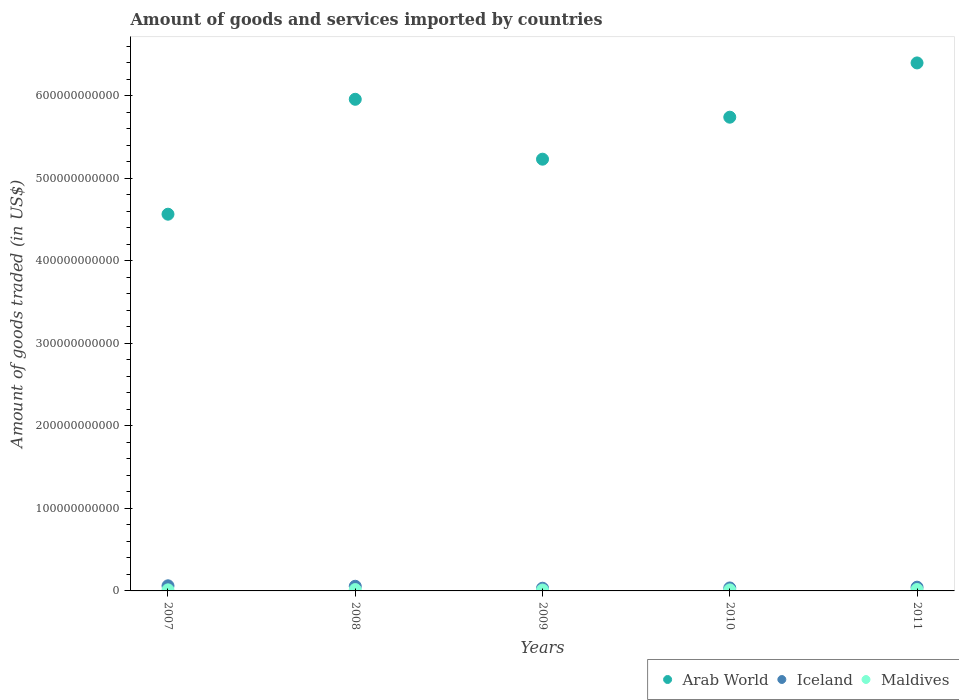Is the number of dotlines equal to the number of legend labels?
Offer a terse response. Yes. What is the total amount of goods and services imported in Iceland in 2011?
Keep it short and to the point. 4.54e+09. Across all years, what is the maximum total amount of goods and services imported in Arab World?
Provide a short and direct response. 6.40e+11. Across all years, what is the minimum total amount of goods and services imported in Arab World?
Your answer should be compact. 4.57e+11. In which year was the total amount of goods and services imported in Maldives maximum?
Give a very brief answer. 2011. In which year was the total amount of goods and services imported in Arab World minimum?
Ensure brevity in your answer.  2007. What is the total total amount of goods and services imported in Maldives in the graph?
Provide a succinct answer. 6.99e+09. What is the difference between the total amount of goods and services imported in Iceland in 2008 and that in 2011?
Offer a terse response. 1.10e+09. What is the difference between the total amount of goods and services imported in Maldives in 2007 and the total amount of goods and services imported in Iceland in 2010?
Your answer should be compact. -2.29e+09. What is the average total amount of goods and services imported in Arab World per year?
Your response must be concise. 5.58e+11. In the year 2010, what is the difference between the total amount of goods and services imported in Maldives and total amount of goods and services imported in Arab World?
Provide a succinct answer. -5.73e+11. What is the ratio of the total amount of goods and services imported in Maldives in 2010 to that in 2011?
Provide a succinct answer. 0.72. Is the difference between the total amount of goods and services imported in Maldives in 2009 and 2011 greater than the difference between the total amount of goods and services imported in Arab World in 2009 and 2011?
Offer a very short reply. Yes. What is the difference between the highest and the second highest total amount of goods and services imported in Arab World?
Provide a succinct answer. 4.41e+1. What is the difference between the highest and the lowest total amount of goods and services imported in Iceland?
Your response must be concise. 2.95e+09. In how many years, is the total amount of goods and services imported in Iceland greater than the average total amount of goods and services imported in Iceland taken over all years?
Offer a very short reply. 2. Is it the case that in every year, the sum of the total amount of goods and services imported in Iceland and total amount of goods and services imported in Maldives  is greater than the total amount of goods and services imported in Arab World?
Offer a very short reply. No. Is the total amount of goods and services imported in Maldives strictly less than the total amount of goods and services imported in Arab World over the years?
Provide a short and direct response. Yes. What is the difference between two consecutive major ticks on the Y-axis?
Your response must be concise. 1.00e+11. Are the values on the major ticks of Y-axis written in scientific E-notation?
Your response must be concise. No. Where does the legend appear in the graph?
Provide a short and direct response. Bottom right. How are the legend labels stacked?
Provide a short and direct response. Horizontal. What is the title of the graph?
Provide a succinct answer. Amount of goods and services imported by countries. Does "Ghana" appear as one of the legend labels in the graph?
Offer a very short reply. No. What is the label or title of the X-axis?
Your answer should be very brief. Years. What is the label or title of the Y-axis?
Your answer should be very brief. Amount of goods traded (in US$). What is the Amount of goods traded (in US$) of Arab World in 2007?
Give a very brief answer. 4.57e+11. What is the Amount of goods traded (in US$) in Iceland in 2007?
Give a very brief answer. 6.21e+09. What is the Amount of goods traded (in US$) in Maldives in 2007?
Ensure brevity in your answer.  1.30e+09. What is the Amount of goods traded (in US$) in Arab World in 2008?
Ensure brevity in your answer.  5.96e+11. What is the Amount of goods traded (in US$) of Iceland in 2008?
Provide a short and direct response. 5.64e+09. What is the Amount of goods traded (in US$) of Maldives in 2008?
Give a very brief answer. 1.65e+09. What is the Amount of goods traded (in US$) of Arab World in 2009?
Give a very brief answer. 5.23e+11. What is the Amount of goods traded (in US$) of Iceland in 2009?
Your response must be concise. 3.26e+09. What is the Amount of goods traded (in US$) in Maldives in 2009?
Ensure brevity in your answer.  1.08e+09. What is the Amount of goods traded (in US$) of Arab World in 2010?
Provide a succinct answer. 5.74e+11. What is the Amount of goods traded (in US$) in Iceland in 2010?
Ensure brevity in your answer.  3.60e+09. What is the Amount of goods traded (in US$) in Maldives in 2010?
Your response must be concise. 1.24e+09. What is the Amount of goods traded (in US$) of Arab World in 2011?
Your response must be concise. 6.40e+11. What is the Amount of goods traded (in US$) of Iceland in 2011?
Ensure brevity in your answer.  4.54e+09. What is the Amount of goods traded (in US$) in Maldives in 2011?
Make the answer very short. 1.72e+09. Across all years, what is the maximum Amount of goods traded (in US$) of Arab World?
Give a very brief answer. 6.40e+11. Across all years, what is the maximum Amount of goods traded (in US$) of Iceland?
Your answer should be very brief. 6.21e+09. Across all years, what is the maximum Amount of goods traded (in US$) in Maldives?
Offer a very short reply. 1.72e+09. Across all years, what is the minimum Amount of goods traded (in US$) of Arab World?
Your answer should be very brief. 4.57e+11. Across all years, what is the minimum Amount of goods traded (in US$) in Iceland?
Ensure brevity in your answer.  3.26e+09. Across all years, what is the minimum Amount of goods traded (in US$) of Maldives?
Ensure brevity in your answer.  1.08e+09. What is the total Amount of goods traded (in US$) of Arab World in the graph?
Ensure brevity in your answer.  2.79e+12. What is the total Amount of goods traded (in US$) of Iceland in the graph?
Make the answer very short. 2.33e+1. What is the total Amount of goods traded (in US$) of Maldives in the graph?
Ensure brevity in your answer.  6.99e+09. What is the difference between the Amount of goods traded (in US$) of Arab World in 2007 and that in 2008?
Ensure brevity in your answer.  -1.39e+11. What is the difference between the Amount of goods traded (in US$) in Iceland in 2007 and that in 2008?
Offer a terse response. 5.66e+08. What is the difference between the Amount of goods traded (in US$) of Maldives in 2007 and that in 2008?
Give a very brief answer. -3.44e+08. What is the difference between the Amount of goods traded (in US$) of Arab World in 2007 and that in 2009?
Ensure brevity in your answer.  -6.67e+1. What is the difference between the Amount of goods traded (in US$) in Iceland in 2007 and that in 2009?
Give a very brief answer. 2.95e+09. What is the difference between the Amount of goods traded (in US$) in Maldives in 2007 and that in 2009?
Your response must be concise. 2.23e+08. What is the difference between the Amount of goods traded (in US$) of Arab World in 2007 and that in 2010?
Keep it short and to the point. -1.18e+11. What is the difference between the Amount of goods traded (in US$) in Iceland in 2007 and that in 2010?
Keep it short and to the point. 2.61e+09. What is the difference between the Amount of goods traded (in US$) of Maldives in 2007 and that in 2010?
Provide a succinct answer. 6.30e+07. What is the difference between the Amount of goods traded (in US$) in Arab World in 2007 and that in 2011?
Give a very brief answer. -1.83e+11. What is the difference between the Amount of goods traded (in US$) of Iceland in 2007 and that in 2011?
Offer a terse response. 1.67e+09. What is the difference between the Amount of goods traded (in US$) in Maldives in 2007 and that in 2011?
Keep it short and to the point. -4.12e+08. What is the difference between the Amount of goods traded (in US$) of Arab World in 2008 and that in 2009?
Offer a terse response. 7.26e+1. What is the difference between the Amount of goods traded (in US$) in Iceland in 2008 and that in 2009?
Ensure brevity in your answer.  2.38e+09. What is the difference between the Amount of goods traded (in US$) of Maldives in 2008 and that in 2009?
Your answer should be very brief. 5.67e+08. What is the difference between the Amount of goods traded (in US$) in Arab World in 2008 and that in 2010?
Make the answer very short. 2.17e+1. What is the difference between the Amount of goods traded (in US$) in Iceland in 2008 and that in 2010?
Give a very brief answer. 2.05e+09. What is the difference between the Amount of goods traded (in US$) of Maldives in 2008 and that in 2010?
Provide a short and direct response. 4.07e+08. What is the difference between the Amount of goods traded (in US$) of Arab World in 2008 and that in 2011?
Give a very brief answer. -4.41e+1. What is the difference between the Amount of goods traded (in US$) in Iceland in 2008 and that in 2011?
Provide a short and direct response. 1.10e+09. What is the difference between the Amount of goods traded (in US$) of Maldives in 2008 and that in 2011?
Offer a terse response. -6.78e+07. What is the difference between the Amount of goods traded (in US$) of Arab World in 2009 and that in 2010?
Make the answer very short. -5.09e+1. What is the difference between the Amount of goods traded (in US$) of Iceland in 2009 and that in 2010?
Make the answer very short. -3.34e+08. What is the difference between the Amount of goods traded (in US$) in Maldives in 2009 and that in 2010?
Ensure brevity in your answer.  -1.60e+08. What is the difference between the Amount of goods traded (in US$) of Arab World in 2009 and that in 2011?
Offer a very short reply. -1.17e+11. What is the difference between the Amount of goods traded (in US$) of Iceland in 2009 and that in 2011?
Keep it short and to the point. -1.28e+09. What is the difference between the Amount of goods traded (in US$) in Maldives in 2009 and that in 2011?
Provide a succinct answer. -6.35e+08. What is the difference between the Amount of goods traded (in US$) of Arab World in 2010 and that in 2011?
Provide a succinct answer. -6.58e+1. What is the difference between the Amount of goods traded (in US$) of Iceland in 2010 and that in 2011?
Ensure brevity in your answer.  -9.44e+08. What is the difference between the Amount of goods traded (in US$) in Maldives in 2010 and that in 2011?
Your response must be concise. -4.75e+08. What is the difference between the Amount of goods traded (in US$) in Arab World in 2007 and the Amount of goods traded (in US$) in Iceland in 2008?
Offer a very short reply. 4.51e+11. What is the difference between the Amount of goods traded (in US$) in Arab World in 2007 and the Amount of goods traded (in US$) in Maldives in 2008?
Your response must be concise. 4.55e+11. What is the difference between the Amount of goods traded (in US$) in Iceland in 2007 and the Amount of goods traded (in US$) in Maldives in 2008?
Make the answer very short. 4.56e+09. What is the difference between the Amount of goods traded (in US$) of Arab World in 2007 and the Amount of goods traded (in US$) of Iceland in 2009?
Your answer should be compact. 4.53e+11. What is the difference between the Amount of goods traded (in US$) of Arab World in 2007 and the Amount of goods traded (in US$) of Maldives in 2009?
Offer a very short reply. 4.55e+11. What is the difference between the Amount of goods traded (in US$) of Iceland in 2007 and the Amount of goods traded (in US$) of Maldives in 2009?
Provide a succinct answer. 5.13e+09. What is the difference between the Amount of goods traded (in US$) in Arab World in 2007 and the Amount of goods traded (in US$) in Iceland in 2010?
Offer a very short reply. 4.53e+11. What is the difference between the Amount of goods traded (in US$) in Arab World in 2007 and the Amount of goods traded (in US$) in Maldives in 2010?
Your response must be concise. 4.55e+11. What is the difference between the Amount of goods traded (in US$) in Iceland in 2007 and the Amount of goods traded (in US$) in Maldives in 2010?
Give a very brief answer. 4.97e+09. What is the difference between the Amount of goods traded (in US$) of Arab World in 2007 and the Amount of goods traded (in US$) of Iceland in 2011?
Offer a very short reply. 4.52e+11. What is the difference between the Amount of goods traded (in US$) of Arab World in 2007 and the Amount of goods traded (in US$) of Maldives in 2011?
Make the answer very short. 4.55e+11. What is the difference between the Amount of goods traded (in US$) in Iceland in 2007 and the Amount of goods traded (in US$) in Maldives in 2011?
Offer a very short reply. 4.49e+09. What is the difference between the Amount of goods traded (in US$) of Arab World in 2008 and the Amount of goods traded (in US$) of Iceland in 2009?
Give a very brief answer. 5.93e+11. What is the difference between the Amount of goods traded (in US$) in Arab World in 2008 and the Amount of goods traded (in US$) in Maldives in 2009?
Your answer should be compact. 5.95e+11. What is the difference between the Amount of goods traded (in US$) of Iceland in 2008 and the Amount of goods traded (in US$) of Maldives in 2009?
Keep it short and to the point. 4.56e+09. What is the difference between the Amount of goods traded (in US$) of Arab World in 2008 and the Amount of goods traded (in US$) of Iceland in 2010?
Provide a short and direct response. 5.92e+11. What is the difference between the Amount of goods traded (in US$) in Arab World in 2008 and the Amount of goods traded (in US$) in Maldives in 2010?
Offer a very short reply. 5.95e+11. What is the difference between the Amount of goods traded (in US$) of Iceland in 2008 and the Amount of goods traded (in US$) of Maldives in 2010?
Your answer should be compact. 4.40e+09. What is the difference between the Amount of goods traded (in US$) in Arab World in 2008 and the Amount of goods traded (in US$) in Iceland in 2011?
Provide a succinct answer. 5.91e+11. What is the difference between the Amount of goods traded (in US$) in Arab World in 2008 and the Amount of goods traded (in US$) in Maldives in 2011?
Make the answer very short. 5.94e+11. What is the difference between the Amount of goods traded (in US$) of Iceland in 2008 and the Amount of goods traded (in US$) of Maldives in 2011?
Keep it short and to the point. 3.93e+09. What is the difference between the Amount of goods traded (in US$) in Arab World in 2009 and the Amount of goods traded (in US$) in Iceland in 2010?
Offer a terse response. 5.20e+11. What is the difference between the Amount of goods traded (in US$) in Arab World in 2009 and the Amount of goods traded (in US$) in Maldives in 2010?
Offer a very short reply. 5.22e+11. What is the difference between the Amount of goods traded (in US$) in Iceland in 2009 and the Amount of goods traded (in US$) in Maldives in 2010?
Provide a succinct answer. 2.02e+09. What is the difference between the Amount of goods traded (in US$) of Arab World in 2009 and the Amount of goods traded (in US$) of Iceland in 2011?
Your answer should be very brief. 5.19e+11. What is the difference between the Amount of goods traded (in US$) in Arab World in 2009 and the Amount of goods traded (in US$) in Maldives in 2011?
Offer a terse response. 5.22e+11. What is the difference between the Amount of goods traded (in US$) of Iceland in 2009 and the Amount of goods traded (in US$) of Maldives in 2011?
Your response must be concise. 1.55e+09. What is the difference between the Amount of goods traded (in US$) of Arab World in 2010 and the Amount of goods traded (in US$) of Iceland in 2011?
Your answer should be very brief. 5.70e+11. What is the difference between the Amount of goods traded (in US$) of Arab World in 2010 and the Amount of goods traded (in US$) of Maldives in 2011?
Your response must be concise. 5.72e+11. What is the difference between the Amount of goods traded (in US$) in Iceland in 2010 and the Amount of goods traded (in US$) in Maldives in 2011?
Provide a succinct answer. 1.88e+09. What is the average Amount of goods traded (in US$) in Arab World per year?
Your response must be concise. 5.58e+11. What is the average Amount of goods traded (in US$) of Iceland per year?
Offer a terse response. 4.65e+09. What is the average Amount of goods traded (in US$) of Maldives per year?
Make the answer very short. 1.40e+09. In the year 2007, what is the difference between the Amount of goods traded (in US$) of Arab World and Amount of goods traded (in US$) of Iceland?
Offer a very short reply. 4.50e+11. In the year 2007, what is the difference between the Amount of goods traded (in US$) of Arab World and Amount of goods traded (in US$) of Maldives?
Provide a succinct answer. 4.55e+11. In the year 2007, what is the difference between the Amount of goods traded (in US$) in Iceland and Amount of goods traded (in US$) in Maldives?
Ensure brevity in your answer.  4.91e+09. In the year 2008, what is the difference between the Amount of goods traded (in US$) in Arab World and Amount of goods traded (in US$) in Iceland?
Provide a short and direct response. 5.90e+11. In the year 2008, what is the difference between the Amount of goods traded (in US$) in Arab World and Amount of goods traded (in US$) in Maldives?
Keep it short and to the point. 5.94e+11. In the year 2008, what is the difference between the Amount of goods traded (in US$) of Iceland and Amount of goods traded (in US$) of Maldives?
Your response must be concise. 4.00e+09. In the year 2009, what is the difference between the Amount of goods traded (in US$) of Arab World and Amount of goods traded (in US$) of Iceland?
Give a very brief answer. 5.20e+11. In the year 2009, what is the difference between the Amount of goods traded (in US$) in Arab World and Amount of goods traded (in US$) in Maldives?
Offer a terse response. 5.22e+11. In the year 2009, what is the difference between the Amount of goods traded (in US$) in Iceland and Amount of goods traded (in US$) in Maldives?
Provide a short and direct response. 2.18e+09. In the year 2010, what is the difference between the Amount of goods traded (in US$) in Arab World and Amount of goods traded (in US$) in Iceland?
Your answer should be very brief. 5.71e+11. In the year 2010, what is the difference between the Amount of goods traded (in US$) of Arab World and Amount of goods traded (in US$) of Maldives?
Make the answer very short. 5.73e+11. In the year 2010, what is the difference between the Amount of goods traded (in US$) in Iceland and Amount of goods traded (in US$) in Maldives?
Your answer should be compact. 2.35e+09. In the year 2011, what is the difference between the Amount of goods traded (in US$) of Arab World and Amount of goods traded (in US$) of Iceland?
Make the answer very short. 6.35e+11. In the year 2011, what is the difference between the Amount of goods traded (in US$) of Arab World and Amount of goods traded (in US$) of Maldives?
Your answer should be very brief. 6.38e+11. In the year 2011, what is the difference between the Amount of goods traded (in US$) of Iceland and Amount of goods traded (in US$) of Maldives?
Ensure brevity in your answer.  2.82e+09. What is the ratio of the Amount of goods traded (in US$) in Arab World in 2007 to that in 2008?
Your answer should be compact. 0.77. What is the ratio of the Amount of goods traded (in US$) in Iceland in 2007 to that in 2008?
Keep it short and to the point. 1.1. What is the ratio of the Amount of goods traded (in US$) of Maldives in 2007 to that in 2008?
Keep it short and to the point. 0.79. What is the ratio of the Amount of goods traded (in US$) in Arab World in 2007 to that in 2009?
Your answer should be very brief. 0.87. What is the ratio of the Amount of goods traded (in US$) in Iceland in 2007 to that in 2009?
Your response must be concise. 1.9. What is the ratio of the Amount of goods traded (in US$) of Maldives in 2007 to that in 2009?
Your answer should be compact. 1.21. What is the ratio of the Amount of goods traded (in US$) in Arab World in 2007 to that in 2010?
Ensure brevity in your answer.  0.8. What is the ratio of the Amount of goods traded (in US$) in Iceland in 2007 to that in 2010?
Your answer should be compact. 1.73. What is the ratio of the Amount of goods traded (in US$) in Maldives in 2007 to that in 2010?
Keep it short and to the point. 1.05. What is the ratio of the Amount of goods traded (in US$) of Arab World in 2007 to that in 2011?
Ensure brevity in your answer.  0.71. What is the ratio of the Amount of goods traded (in US$) of Iceland in 2007 to that in 2011?
Ensure brevity in your answer.  1.37. What is the ratio of the Amount of goods traded (in US$) of Maldives in 2007 to that in 2011?
Make the answer very short. 0.76. What is the ratio of the Amount of goods traded (in US$) of Arab World in 2008 to that in 2009?
Your response must be concise. 1.14. What is the ratio of the Amount of goods traded (in US$) of Iceland in 2008 to that in 2009?
Your response must be concise. 1.73. What is the ratio of the Amount of goods traded (in US$) of Maldives in 2008 to that in 2009?
Provide a short and direct response. 1.52. What is the ratio of the Amount of goods traded (in US$) of Arab World in 2008 to that in 2010?
Make the answer very short. 1.04. What is the ratio of the Amount of goods traded (in US$) in Iceland in 2008 to that in 2010?
Offer a very short reply. 1.57. What is the ratio of the Amount of goods traded (in US$) in Maldives in 2008 to that in 2010?
Give a very brief answer. 1.33. What is the ratio of the Amount of goods traded (in US$) in Arab World in 2008 to that in 2011?
Give a very brief answer. 0.93. What is the ratio of the Amount of goods traded (in US$) in Iceland in 2008 to that in 2011?
Your answer should be compact. 1.24. What is the ratio of the Amount of goods traded (in US$) in Maldives in 2008 to that in 2011?
Give a very brief answer. 0.96. What is the ratio of the Amount of goods traded (in US$) in Arab World in 2009 to that in 2010?
Ensure brevity in your answer.  0.91. What is the ratio of the Amount of goods traded (in US$) in Iceland in 2009 to that in 2010?
Make the answer very short. 0.91. What is the ratio of the Amount of goods traded (in US$) of Maldives in 2009 to that in 2010?
Provide a short and direct response. 0.87. What is the ratio of the Amount of goods traded (in US$) of Arab World in 2009 to that in 2011?
Your response must be concise. 0.82. What is the ratio of the Amount of goods traded (in US$) in Iceland in 2009 to that in 2011?
Provide a succinct answer. 0.72. What is the ratio of the Amount of goods traded (in US$) in Maldives in 2009 to that in 2011?
Offer a terse response. 0.63. What is the ratio of the Amount of goods traded (in US$) in Arab World in 2010 to that in 2011?
Provide a short and direct response. 0.9. What is the ratio of the Amount of goods traded (in US$) in Iceland in 2010 to that in 2011?
Make the answer very short. 0.79. What is the ratio of the Amount of goods traded (in US$) in Maldives in 2010 to that in 2011?
Offer a very short reply. 0.72. What is the difference between the highest and the second highest Amount of goods traded (in US$) of Arab World?
Your answer should be very brief. 4.41e+1. What is the difference between the highest and the second highest Amount of goods traded (in US$) of Iceland?
Make the answer very short. 5.66e+08. What is the difference between the highest and the second highest Amount of goods traded (in US$) in Maldives?
Make the answer very short. 6.78e+07. What is the difference between the highest and the lowest Amount of goods traded (in US$) of Arab World?
Provide a short and direct response. 1.83e+11. What is the difference between the highest and the lowest Amount of goods traded (in US$) of Iceland?
Keep it short and to the point. 2.95e+09. What is the difference between the highest and the lowest Amount of goods traded (in US$) of Maldives?
Make the answer very short. 6.35e+08. 